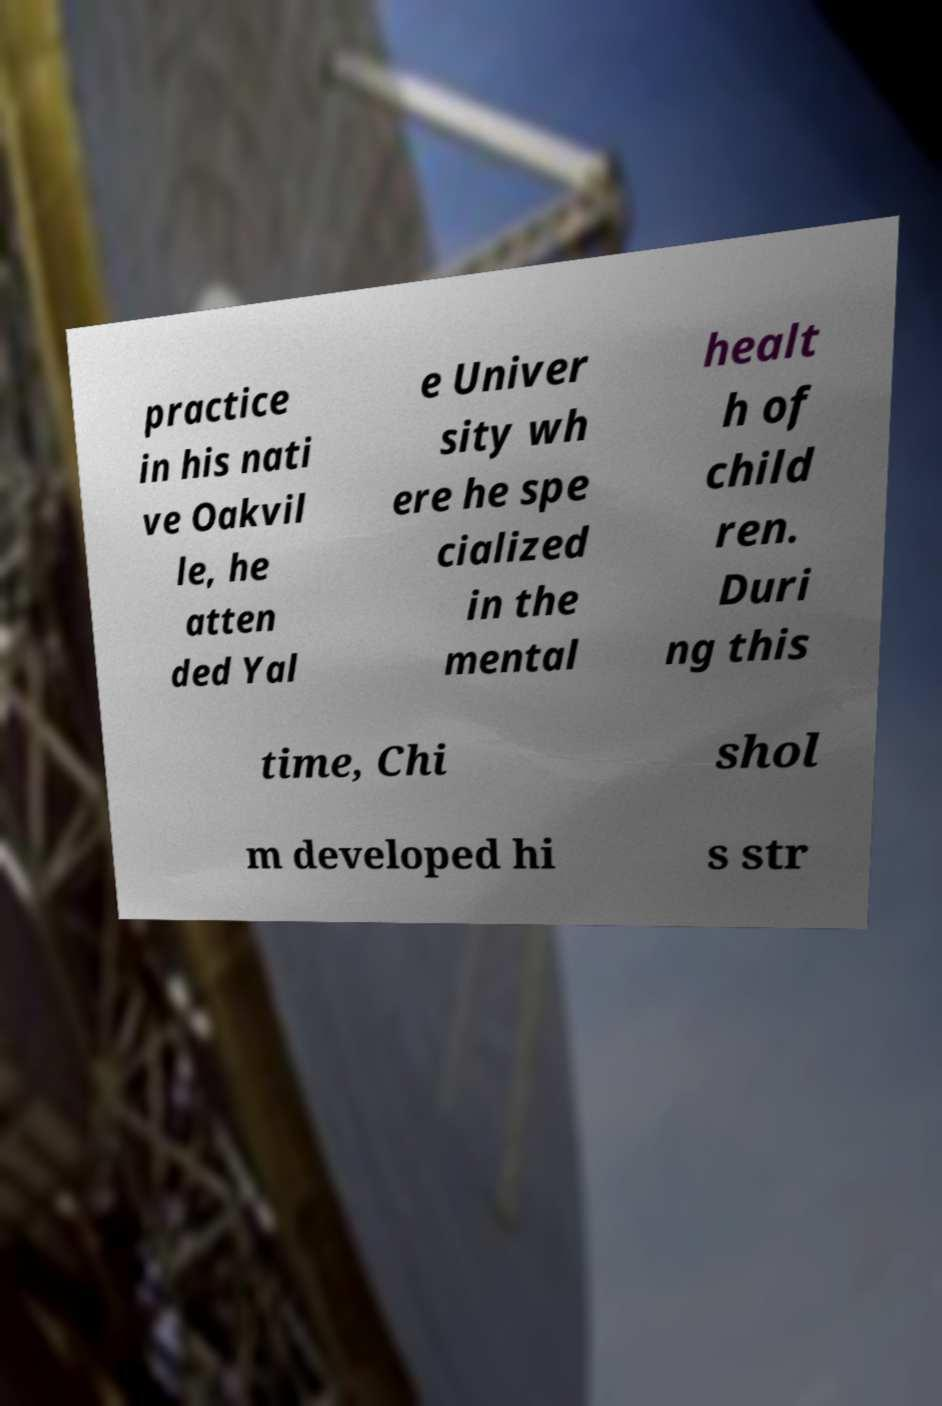For documentation purposes, I need the text within this image transcribed. Could you provide that? practice in his nati ve Oakvil le, he atten ded Yal e Univer sity wh ere he spe cialized in the mental healt h of child ren. Duri ng this time, Chi shol m developed hi s str 